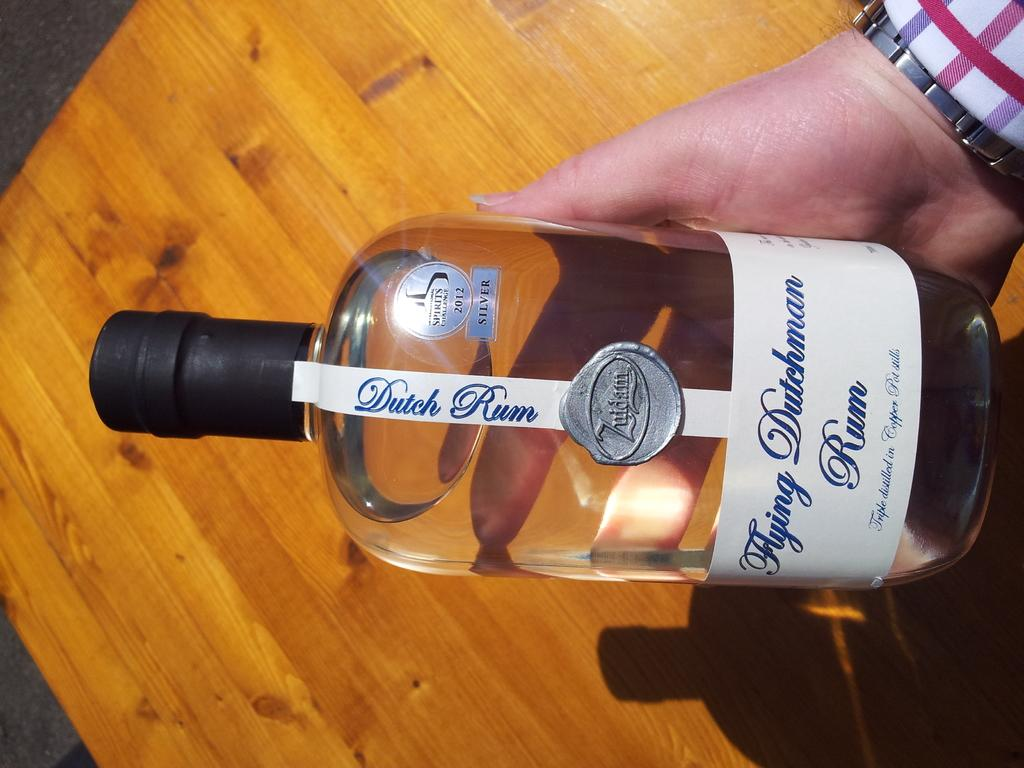Provide a one-sentence caption for the provided image. A person holding a dutch rum drink in its hand. 